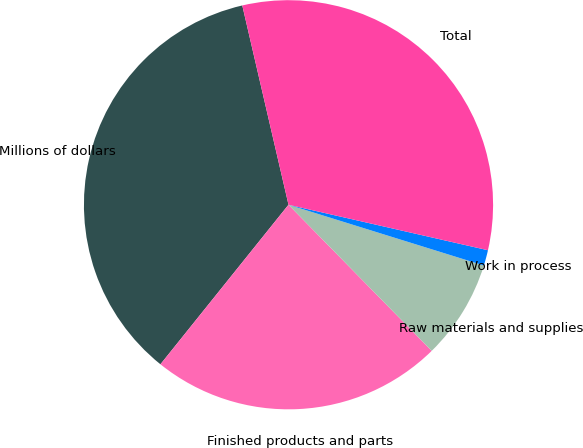<chart> <loc_0><loc_0><loc_500><loc_500><pie_chart><fcel>Millions of dollars<fcel>Finished products and parts<fcel>Raw materials and supplies<fcel>Work in process<fcel>Total<nl><fcel>35.61%<fcel>23.11%<fcel>7.86%<fcel>1.23%<fcel>32.2%<nl></chart> 